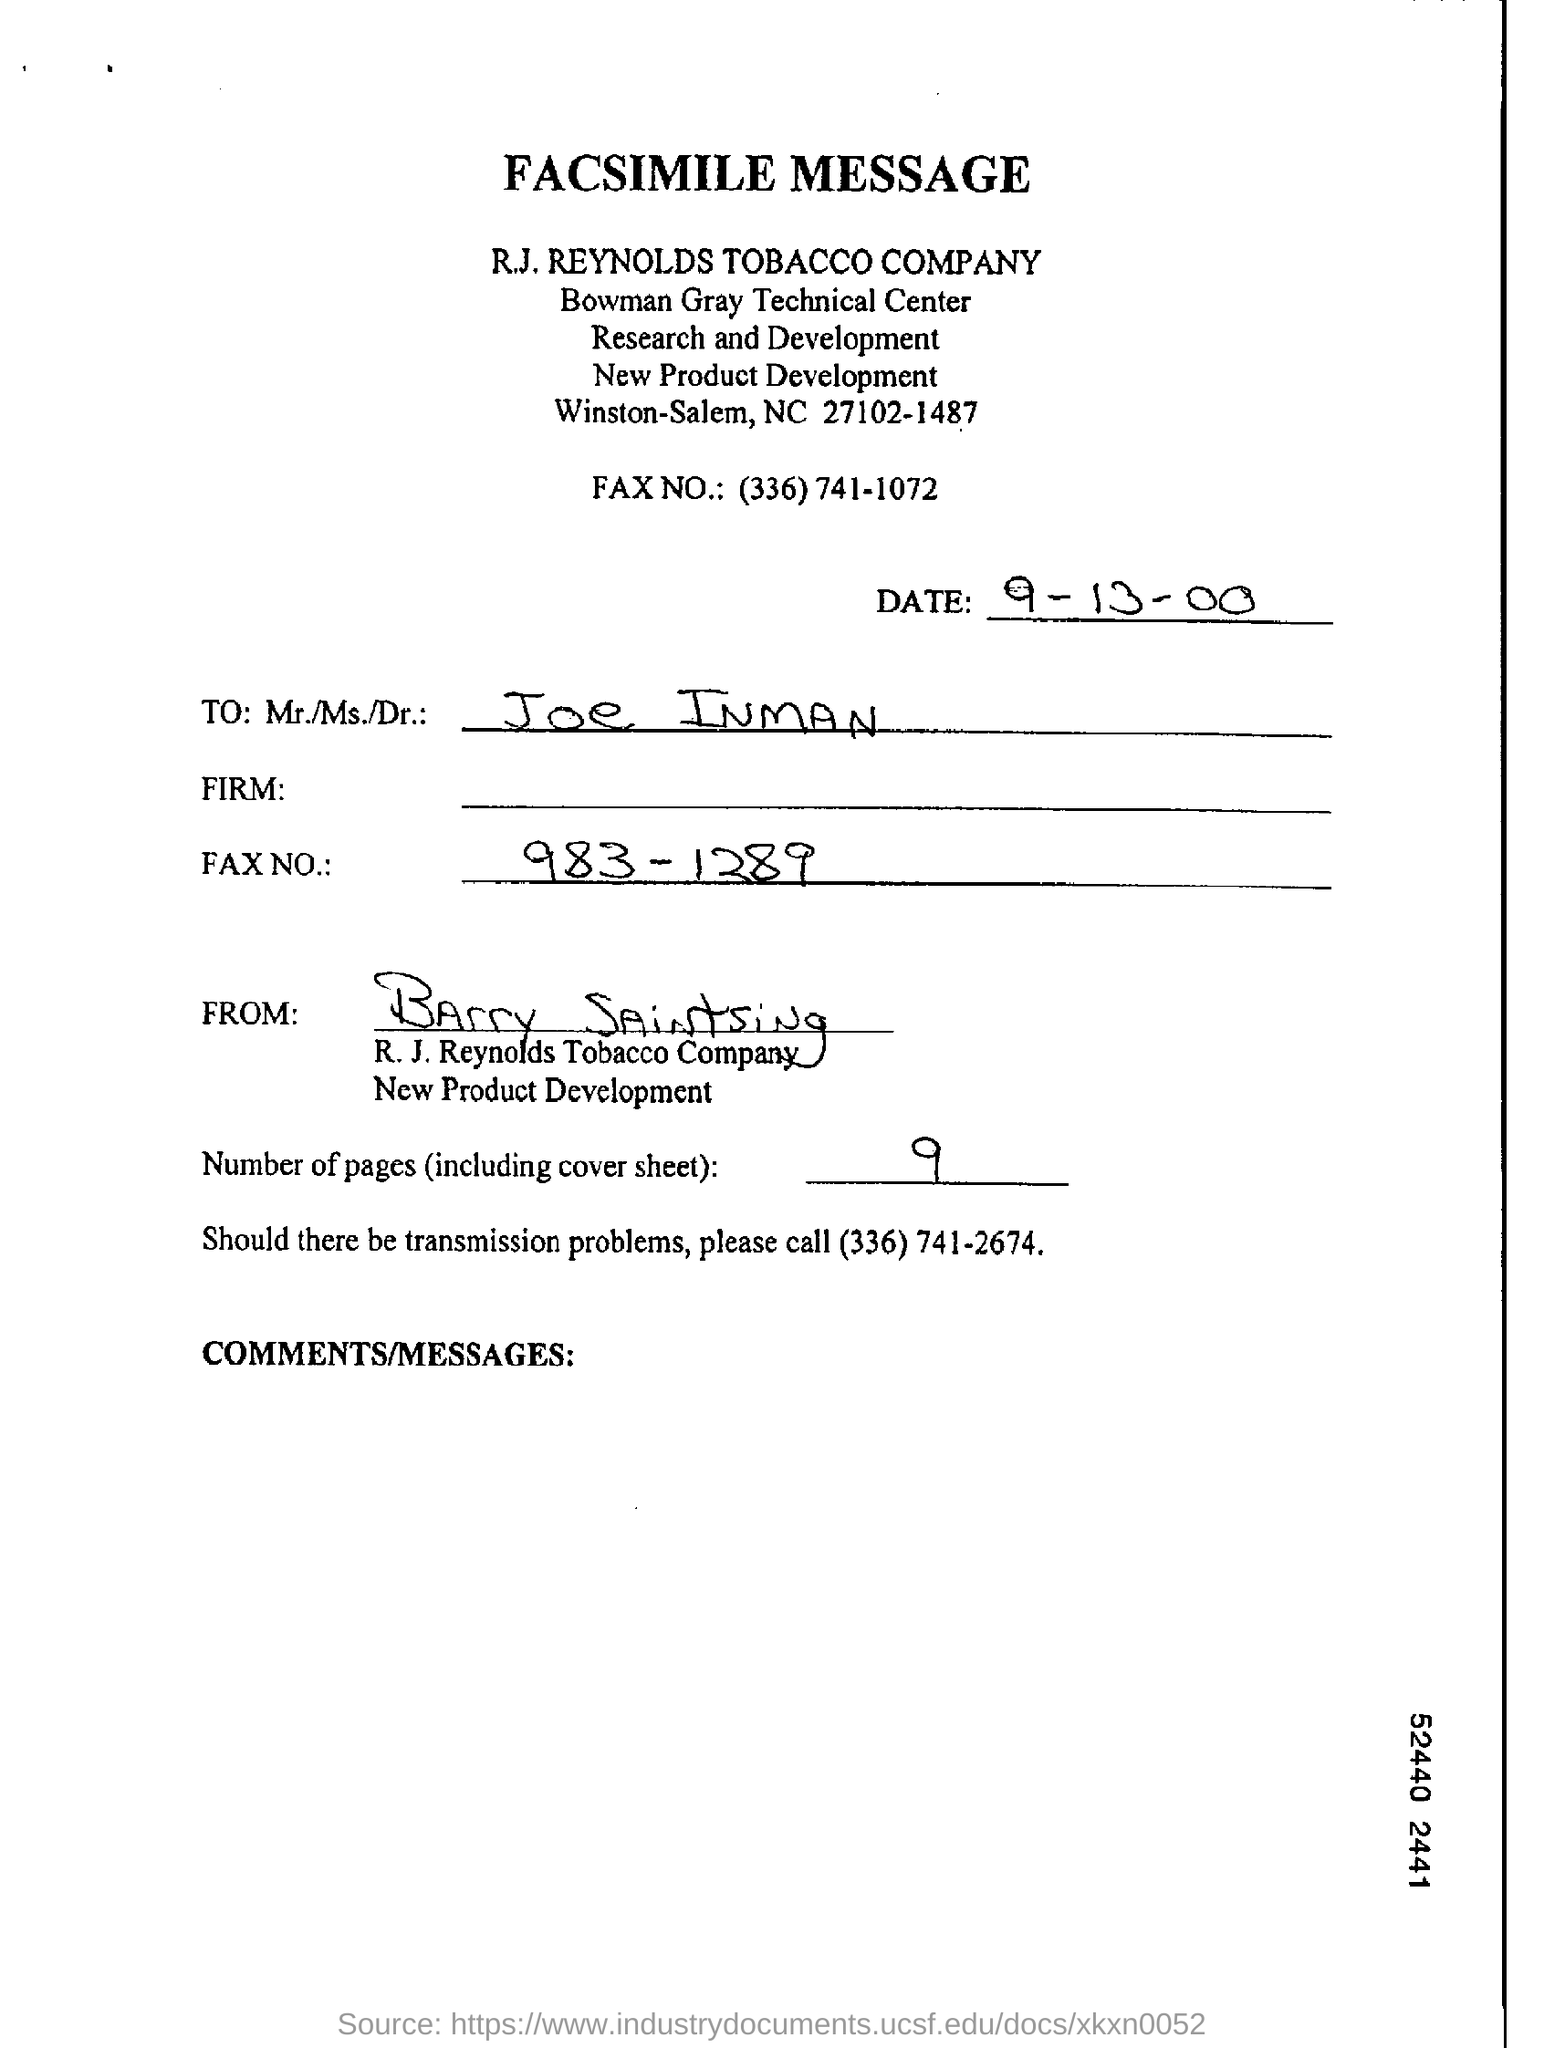What is the date on the document?
Provide a short and direct response. 9-13-00. Who is this letter from?
Offer a terse response. Barry Saintsing. To Whom is this letter addressed to?
Keep it short and to the point. Joe Inman. 